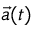<formula> <loc_0><loc_0><loc_500><loc_500>\vec { a } ( t )</formula> 